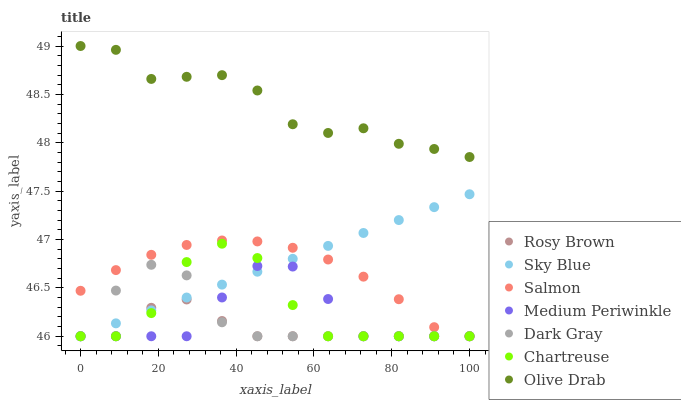Does Rosy Brown have the minimum area under the curve?
Answer yes or no. Yes. Does Olive Drab have the maximum area under the curve?
Answer yes or no. Yes. Does Salmon have the minimum area under the curve?
Answer yes or no. No. Does Salmon have the maximum area under the curve?
Answer yes or no. No. Is Sky Blue the smoothest?
Answer yes or no. Yes. Is Chartreuse the roughest?
Answer yes or no. Yes. Is Rosy Brown the smoothest?
Answer yes or no. No. Is Rosy Brown the roughest?
Answer yes or no. No. Does Medium Periwinkle have the lowest value?
Answer yes or no. Yes. Does Olive Drab have the lowest value?
Answer yes or no. No. Does Olive Drab have the highest value?
Answer yes or no. Yes. Does Salmon have the highest value?
Answer yes or no. No. Is Sky Blue less than Olive Drab?
Answer yes or no. Yes. Is Olive Drab greater than Sky Blue?
Answer yes or no. Yes. Does Sky Blue intersect Rosy Brown?
Answer yes or no. Yes. Is Sky Blue less than Rosy Brown?
Answer yes or no. No. Is Sky Blue greater than Rosy Brown?
Answer yes or no. No. Does Sky Blue intersect Olive Drab?
Answer yes or no. No. 